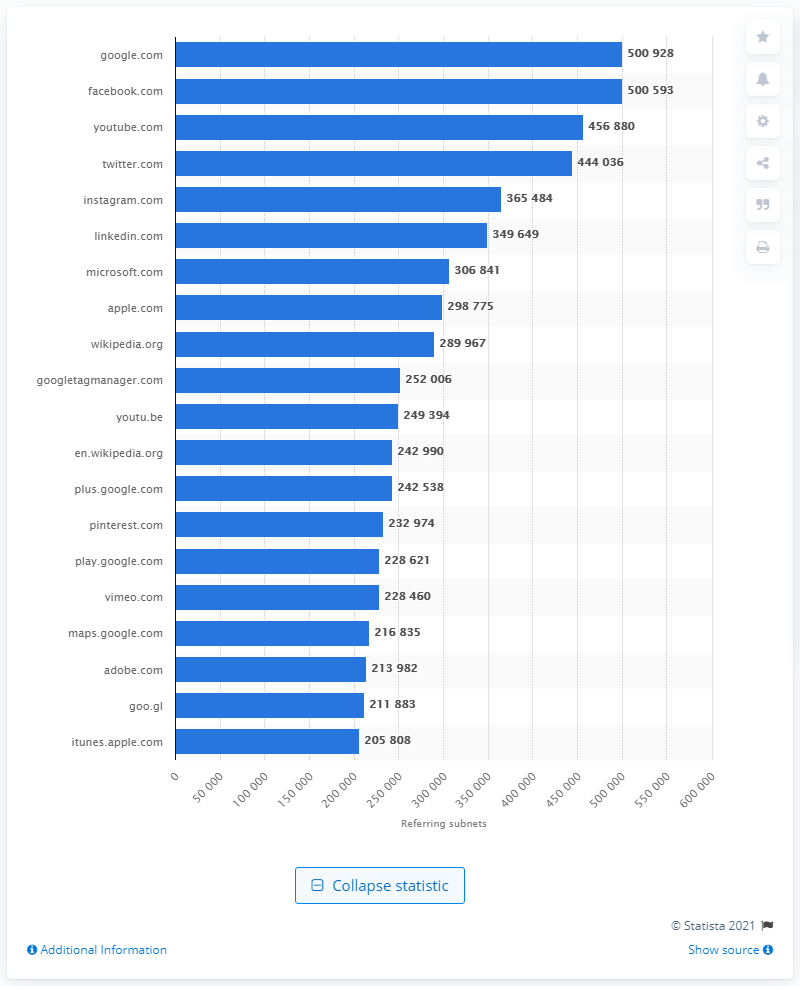Point out several critical features in this image. According to the data available as of April 2021, Google.com was ranked first among all domains worldwide in terms of the number of referring subnets. 